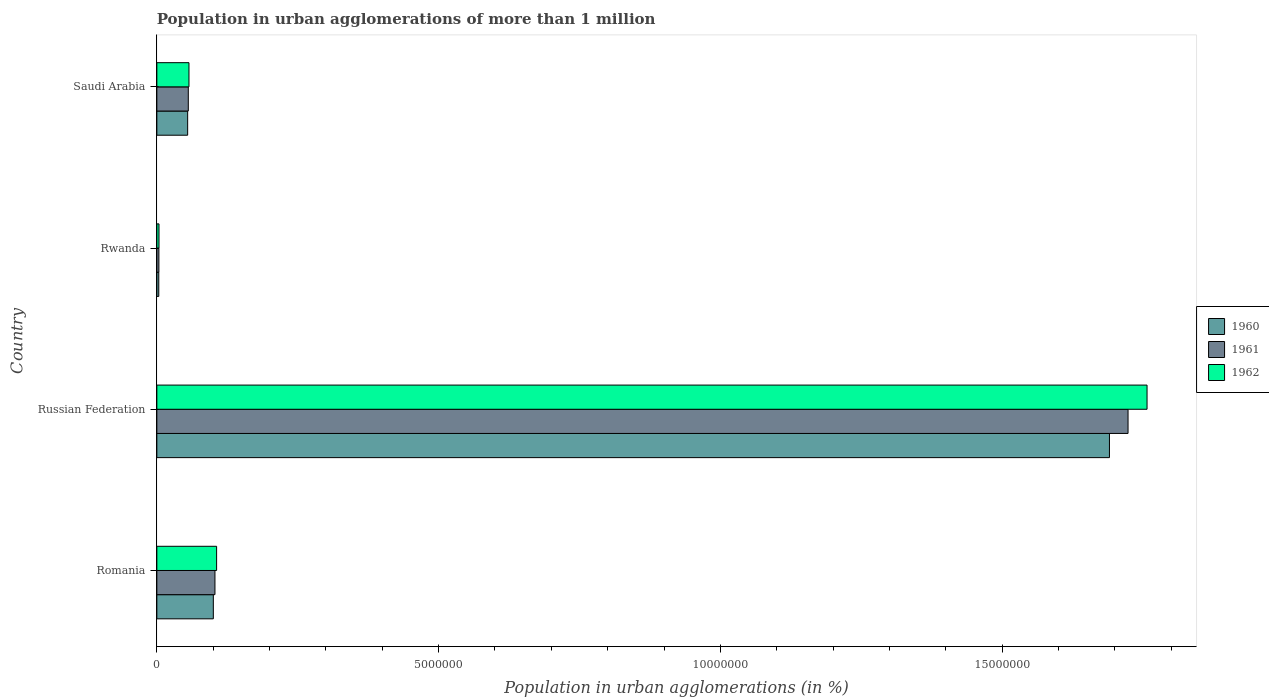How many different coloured bars are there?
Your answer should be very brief. 3. Are the number of bars per tick equal to the number of legend labels?
Your answer should be compact. Yes. Are the number of bars on each tick of the Y-axis equal?
Keep it short and to the point. Yes. How many bars are there on the 4th tick from the top?
Offer a very short reply. 3. How many bars are there on the 1st tick from the bottom?
Provide a succinct answer. 3. What is the label of the 1st group of bars from the top?
Your answer should be compact. Saudi Arabia. In how many cases, is the number of bars for a given country not equal to the number of legend labels?
Offer a terse response. 0. What is the population in urban agglomerations in 1962 in Russian Federation?
Your response must be concise. 1.76e+07. Across all countries, what is the maximum population in urban agglomerations in 1961?
Make the answer very short. 1.72e+07. Across all countries, what is the minimum population in urban agglomerations in 1962?
Provide a succinct answer. 3.83e+04. In which country was the population in urban agglomerations in 1962 maximum?
Give a very brief answer. Russian Federation. In which country was the population in urban agglomerations in 1961 minimum?
Offer a very short reply. Rwanda. What is the total population in urban agglomerations in 1960 in the graph?
Your answer should be compact. 1.85e+07. What is the difference between the population in urban agglomerations in 1962 in Rwanda and that in Saudi Arabia?
Offer a very short reply. -5.32e+05. What is the difference between the population in urban agglomerations in 1960 in Saudi Arabia and the population in urban agglomerations in 1962 in Rwanda?
Offer a very short reply. 5.08e+05. What is the average population in urban agglomerations in 1962 per country?
Your answer should be compact. 4.81e+06. What is the difference between the population in urban agglomerations in 1962 and population in urban agglomerations in 1960 in Romania?
Offer a terse response. 5.83e+04. What is the ratio of the population in urban agglomerations in 1960 in Romania to that in Rwanda?
Your answer should be compact. 29.21. Is the population in urban agglomerations in 1962 in Romania less than that in Saudi Arabia?
Keep it short and to the point. No. What is the difference between the highest and the second highest population in urban agglomerations in 1961?
Give a very brief answer. 1.62e+07. What is the difference between the highest and the lowest population in urban agglomerations in 1962?
Offer a terse response. 1.75e+07. What does the 2nd bar from the bottom in Saudi Arabia represents?
Your answer should be very brief. 1961. How many bars are there?
Your answer should be very brief. 12. Are all the bars in the graph horizontal?
Make the answer very short. Yes. Does the graph contain grids?
Your response must be concise. No. Where does the legend appear in the graph?
Offer a terse response. Center right. How many legend labels are there?
Your answer should be very brief. 3. How are the legend labels stacked?
Offer a very short reply. Vertical. What is the title of the graph?
Keep it short and to the point. Population in urban agglomerations of more than 1 million. Does "2007" appear as one of the legend labels in the graph?
Give a very brief answer. No. What is the label or title of the X-axis?
Your answer should be very brief. Population in urban agglomerations (in %). What is the Population in urban agglomerations (in %) in 1960 in Romania?
Your answer should be compact. 1.00e+06. What is the Population in urban agglomerations (in %) of 1961 in Romania?
Your answer should be very brief. 1.03e+06. What is the Population in urban agglomerations (in %) in 1962 in Romania?
Offer a terse response. 1.06e+06. What is the Population in urban agglomerations (in %) of 1960 in Russian Federation?
Provide a succinct answer. 1.69e+07. What is the Population in urban agglomerations (in %) in 1961 in Russian Federation?
Offer a terse response. 1.72e+07. What is the Population in urban agglomerations (in %) in 1962 in Russian Federation?
Your answer should be compact. 1.76e+07. What is the Population in urban agglomerations (in %) of 1960 in Rwanda?
Provide a short and direct response. 3.43e+04. What is the Population in urban agglomerations (in %) of 1961 in Rwanda?
Your answer should be compact. 3.63e+04. What is the Population in urban agglomerations (in %) in 1962 in Rwanda?
Provide a short and direct response. 3.83e+04. What is the Population in urban agglomerations (in %) of 1960 in Saudi Arabia?
Your answer should be very brief. 5.47e+05. What is the Population in urban agglomerations (in %) in 1961 in Saudi Arabia?
Your answer should be very brief. 5.58e+05. What is the Population in urban agglomerations (in %) in 1962 in Saudi Arabia?
Provide a succinct answer. 5.70e+05. Across all countries, what is the maximum Population in urban agglomerations (in %) of 1960?
Make the answer very short. 1.69e+07. Across all countries, what is the maximum Population in urban agglomerations (in %) in 1961?
Offer a very short reply. 1.72e+07. Across all countries, what is the maximum Population in urban agglomerations (in %) in 1962?
Your answer should be compact. 1.76e+07. Across all countries, what is the minimum Population in urban agglomerations (in %) of 1960?
Keep it short and to the point. 3.43e+04. Across all countries, what is the minimum Population in urban agglomerations (in %) in 1961?
Keep it short and to the point. 3.63e+04. Across all countries, what is the minimum Population in urban agglomerations (in %) of 1962?
Provide a short and direct response. 3.83e+04. What is the total Population in urban agglomerations (in %) in 1960 in the graph?
Your answer should be compact. 1.85e+07. What is the total Population in urban agglomerations (in %) of 1961 in the graph?
Keep it short and to the point. 1.89e+07. What is the total Population in urban agglomerations (in %) in 1962 in the graph?
Provide a short and direct response. 1.92e+07. What is the difference between the Population in urban agglomerations (in %) in 1960 in Romania and that in Russian Federation?
Give a very brief answer. -1.59e+07. What is the difference between the Population in urban agglomerations (in %) of 1961 in Romania and that in Russian Federation?
Your answer should be very brief. -1.62e+07. What is the difference between the Population in urban agglomerations (in %) in 1962 in Romania and that in Russian Federation?
Offer a very short reply. -1.65e+07. What is the difference between the Population in urban agglomerations (in %) in 1960 in Romania and that in Rwanda?
Your response must be concise. 9.68e+05. What is the difference between the Population in urban agglomerations (in %) in 1961 in Romania and that in Rwanda?
Give a very brief answer. 9.95e+05. What is the difference between the Population in urban agglomerations (in %) of 1962 in Romania and that in Rwanda?
Your answer should be compact. 1.02e+06. What is the difference between the Population in urban agglomerations (in %) of 1960 in Romania and that in Saudi Arabia?
Your answer should be compact. 4.56e+05. What is the difference between the Population in urban agglomerations (in %) in 1961 in Romania and that in Saudi Arabia?
Give a very brief answer. 4.73e+05. What is the difference between the Population in urban agglomerations (in %) of 1962 in Romania and that in Saudi Arabia?
Offer a terse response. 4.91e+05. What is the difference between the Population in urban agglomerations (in %) of 1960 in Russian Federation and that in Rwanda?
Your answer should be very brief. 1.69e+07. What is the difference between the Population in urban agglomerations (in %) of 1961 in Russian Federation and that in Rwanda?
Offer a terse response. 1.72e+07. What is the difference between the Population in urban agglomerations (in %) of 1962 in Russian Federation and that in Rwanda?
Keep it short and to the point. 1.75e+07. What is the difference between the Population in urban agglomerations (in %) of 1960 in Russian Federation and that in Saudi Arabia?
Your response must be concise. 1.64e+07. What is the difference between the Population in urban agglomerations (in %) of 1961 in Russian Federation and that in Saudi Arabia?
Offer a very short reply. 1.67e+07. What is the difference between the Population in urban agglomerations (in %) in 1962 in Russian Federation and that in Saudi Arabia?
Make the answer very short. 1.70e+07. What is the difference between the Population in urban agglomerations (in %) in 1960 in Rwanda and that in Saudi Arabia?
Offer a terse response. -5.12e+05. What is the difference between the Population in urban agglomerations (in %) in 1961 in Rwanda and that in Saudi Arabia?
Your answer should be very brief. -5.22e+05. What is the difference between the Population in urban agglomerations (in %) in 1962 in Rwanda and that in Saudi Arabia?
Offer a very short reply. -5.32e+05. What is the difference between the Population in urban agglomerations (in %) of 1960 in Romania and the Population in urban agglomerations (in %) of 1961 in Russian Federation?
Your answer should be very brief. -1.62e+07. What is the difference between the Population in urban agglomerations (in %) of 1960 in Romania and the Population in urban agglomerations (in %) of 1962 in Russian Federation?
Keep it short and to the point. -1.66e+07. What is the difference between the Population in urban agglomerations (in %) in 1961 in Romania and the Population in urban agglomerations (in %) in 1962 in Russian Federation?
Provide a short and direct response. -1.65e+07. What is the difference between the Population in urban agglomerations (in %) in 1960 in Romania and the Population in urban agglomerations (in %) in 1961 in Rwanda?
Keep it short and to the point. 9.66e+05. What is the difference between the Population in urban agglomerations (in %) in 1960 in Romania and the Population in urban agglomerations (in %) in 1962 in Rwanda?
Your answer should be very brief. 9.64e+05. What is the difference between the Population in urban agglomerations (in %) of 1961 in Romania and the Population in urban agglomerations (in %) of 1962 in Rwanda?
Offer a terse response. 9.93e+05. What is the difference between the Population in urban agglomerations (in %) of 1960 in Romania and the Population in urban agglomerations (in %) of 1961 in Saudi Arabia?
Give a very brief answer. 4.44e+05. What is the difference between the Population in urban agglomerations (in %) in 1960 in Romania and the Population in urban agglomerations (in %) in 1962 in Saudi Arabia?
Ensure brevity in your answer.  4.32e+05. What is the difference between the Population in urban agglomerations (in %) in 1961 in Romania and the Population in urban agglomerations (in %) in 1962 in Saudi Arabia?
Provide a short and direct response. 4.61e+05. What is the difference between the Population in urban agglomerations (in %) in 1960 in Russian Federation and the Population in urban agglomerations (in %) in 1961 in Rwanda?
Provide a succinct answer. 1.69e+07. What is the difference between the Population in urban agglomerations (in %) in 1960 in Russian Federation and the Population in urban agglomerations (in %) in 1962 in Rwanda?
Your answer should be compact. 1.69e+07. What is the difference between the Population in urban agglomerations (in %) in 1961 in Russian Federation and the Population in urban agglomerations (in %) in 1962 in Rwanda?
Provide a short and direct response. 1.72e+07. What is the difference between the Population in urban agglomerations (in %) in 1960 in Russian Federation and the Population in urban agglomerations (in %) in 1961 in Saudi Arabia?
Offer a very short reply. 1.63e+07. What is the difference between the Population in urban agglomerations (in %) of 1960 in Russian Federation and the Population in urban agglomerations (in %) of 1962 in Saudi Arabia?
Offer a terse response. 1.63e+07. What is the difference between the Population in urban agglomerations (in %) of 1961 in Russian Federation and the Population in urban agglomerations (in %) of 1962 in Saudi Arabia?
Make the answer very short. 1.67e+07. What is the difference between the Population in urban agglomerations (in %) of 1960 in Rwanda and the Population in urban agglomerations (in %) of 1961 in Saudi Arabia?
Offer a terse response. -5.24e+05. What is the difference between the Population in urban agglomerations (in %) of 1960 in Rwanda and the Population in urban agglomerations (in %) of 1962 in Saudi Arabia?
Provide a short and direct response. -5.36e+05. What is the difference between the Population in urban agglomerations (in %) in 1961 in Rwanda and the Population in urban agglomerations (in %) in 1962 in Saudi Arabia?
Provide a short and direct response. -5.34e+05. What is the average Population in urban agglomerations (in %) in 1960 per country?
Give a very brief answer. 4.62e+06. What is the average Population in urban agglomerations (in %) of 1961 per country?
Ensure brevity in your answer.  4.71e+06. What is the average Population in urban agglomerations (in %) in 1962 per country?
Offer a very short reply. 4.81e+06. What is the difference between the Population in urban agglomerations (in %) in 1960 and Population in urban agglomerations (in %) in 1961 in Romania?
Your answer should be very brief. -2.87e+04. What is the difference between the Population in urban agglomerations (in %) of 1960 and Population in urban agglomerations (in %) of 1962 in Romania?
Your response must be concise. -5.83e+04. What is the difference between the Population in urban agglomerations (in %) of 1961 and Population in urban agglomerations (in %) of 1962 in Romania?
Offer a very short reply. -2.96e+04. What is the difference between the Population in urban agglomerations (in %) of 1960 and Population in urban agglomerations (in %) of 1961 in Russian Federation?
Give a very brief answer. -3.30e+05. What is the difference between the Population in urban agglomerations (in %) in 1960 and Population in urban agglomerations (in %) in 1962 in Russian Federation?
Make the answer very short. -6.67e+05. What is the difference between the Population in urban agglomerations (in %) of 1961 and Population in urban agglomerations (in %) of 1962 in Russian Federation?
Offer a terse response. -3.37e+05. What is the difference between the Population in urban agglomerations (in %) in 1960 and Population in urban agglomerations (in %) in 1961 in Rwanda?
Ensure brevity in your answer.  -1932. What is the difference between the Population in urban agglomerations (in %) in 1960 and Population in urban agglomerations (in %) in 1962 in Rwanda?
Make the answer very short. -3976. What is the difference between the Population in urban agglomerations (in %) of 1961 and Population in urban agglomerations (in %) of 1962 in Rwanda?
Offer a very short reply. -2044. What is the difference between the Population in urban agglomerations (in %) in 1960 and Population in urban agglomerations (in %) in 1961 in Saudi Arabia?
Keep it short and to the point. -1.15e+04. What is the difference between the Population in urban agglomerations (in %) of 1960 and Population in urban agglomerations (in %) of 1962 in Saudi Arabia?
Your answer should be very brief. -2.33e+04. What is the difference between the Population in urban agglomerations (in %) in 1961 and Population in urban agglomerations (in %) in 1962 in Saudi Arabia?
Provide a succinct answer. -1.18e+04. What is the ratio of the Population in urban agglomerations (in %) in 1960 in Romania to that in Russian Federation?
Your answer should be very brief. 0.06. What is the ratio of the Population in urban agglomerations (in %) in 1961 in Romania to that in Russian Federation?
Your response must be concise. 0.06. What is the ratio of the Population in urban agglomerations (in %) in 1962 in Romania to that in Russian Federation?
Your answer should be compact. 0.06. What is the ratio of the Population in urban agglomerations (in %) of 1960 in Romania to that in Rwanda?
Offer a very short reply. 29.21. What is the ratio of the Population in urban agglomerations (in %) of 1961 in Romania to that in Rwanda?
Make the answer very short. 28.44. What is the ratio of the Population in urban agglomerations (in %) of 1962 in Romania to that in Rwanda?
Your response must be concise. 27.69. What is the ratio of the Population in urban agglomerations (in %) in 1960 in Romania to that in Saudi Arabia?
Ensure brevity in your answer.  1.83. What is the ratio of the Population in urban agglomerations (in %) in 1961 in Romania to that in Saudi Arabia?
Your answer should be very brief. 1.85. What is the ratio of the Population in urban agglomerations (in %) of 1962 in Romania to that in Saudi Arabia?
Your response must be concise. 1.86. What is the ratio of the Population in urban agglomerations (in %) of 1960 in Russian Federation to that in Rwanda?
Offer a very short reply. 492.55. What is the ratio of the Population in urban agglomerations (in %) of 1961 in Russian Federation to that in Rwanda?
Give a very brief answer. 475.39. What is the ratio of the Population in urban agglomerations (in %) in 1962 in Russian Federation to that in Rwanda?
Keep it short and to the point. 458.83. What is the ratio of the Population in urban agglomerations (in %) in 1960 in Russian Federation to that in Saudi Arabia?
Offer a very short reply. 30.92. What is the ratio of the Population in urban agglomerations (in %) in 1961 in Russian Federation to that in Saudi Arabia?
Keep it short and to the point. 30.88. What is the ratio of the Population in urban agglomerations (in %) of 1962 in Russian Federation to that in Saudi Arabia?
Your answer should be compact. 30.83. What is the ratio of the Population in urban agglomerations (in %) of 1960 in Rwanda to that in Saudi Arabia?
Ensure brevity in your answer.  0.06. What is the ratio of the Population in urban agglomerations (in %) of 1961 in Rwanda to that in Saudi Arabia?
Make the answer very short. 0.07. What is the ratio of the Population in urban agglomerations (in %) in 1962 in Rwanda to that in Saudi Arabia?
Your answer should be very brief. 0.07. What is the difference between the highest and the second highest Population in urban agglomerations (in %) of 1960?
Your answer should be very brief. 1.59e+07. What is the difference between the highest and the second highest Population in urban agglomerations (in %) in 1961?
Your answer should be very brief. 1.62e+07. What is the difference between the highest and the second highest Population in urban agglomerations (in %) in 1962?
Ensure brevity in your answer.  1.65e+07. What is the difference between the highest and the lowest Population in urban agglomerations (in %) of 1960?
Your answer should be compact. 1.69e+07. What is the difference between the highest and the lowest Population in urban agglomerations (in %) in 1961?
Your answer should be very brief. 1.72e+07. What is the difference between the highest and the lowest Population in urban agglomerations (in %) in 1962?
Provide a short and direct response. 1.75e+07. 